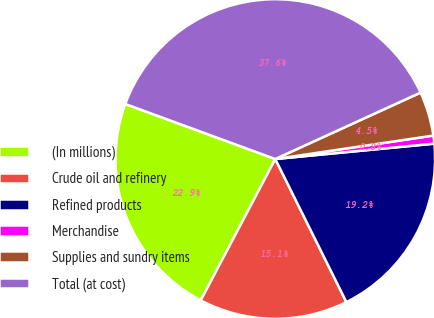Convert chart. <chart><loc_0><loc_0><loc_500><loc_500><pie_chart><fcel>(In millions)<fcel>Crude oil and refinery<fcel>Refined products<fcel>Merchandise<fcel>Supplies and sundry items<fcel>Total (at cost)<nl><fcel>22.87%<fcel>15.07%<fcel>19.19%<fcel>0.81%<fcel>4.48%<fcel>37.58%<nl></chart> 